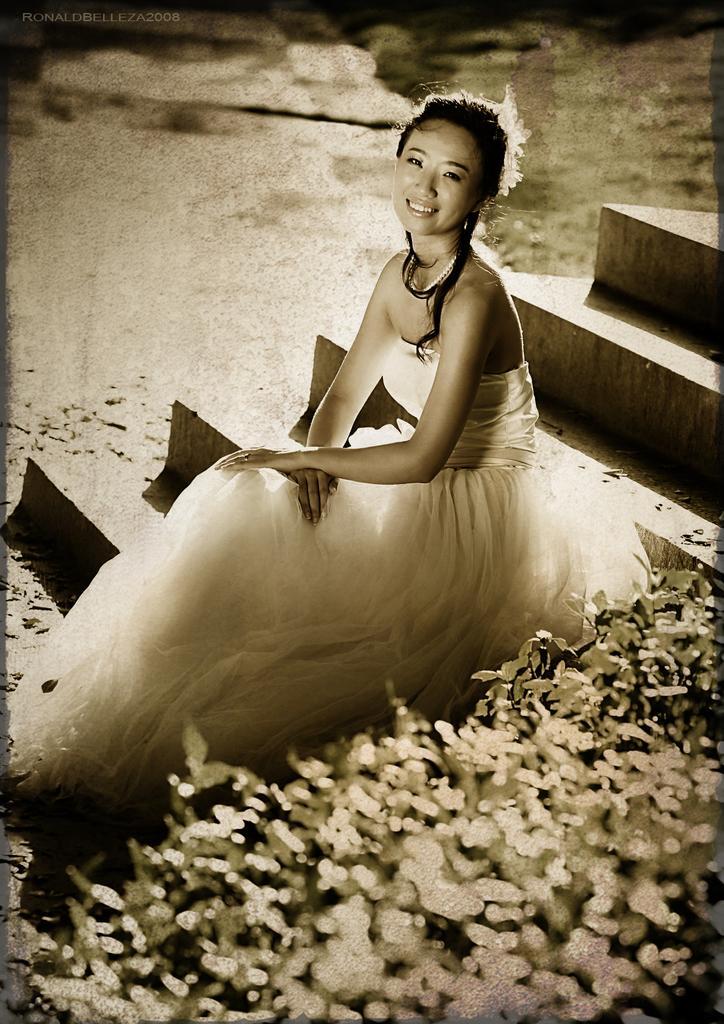In one or two sentences, can you explain what this image depicts? In this image I can see a woman wearing a white color gown sitting on staircase , on the right side I can see plants. 